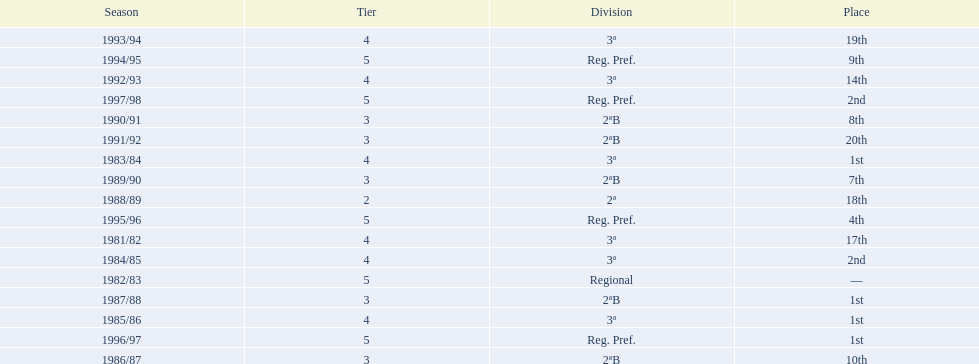In what years did the team finish 17th or worse? 1981/82, 1988/89, 1991/92, 1993/94. Of those, in which year the team finish worse? 1991/92. 